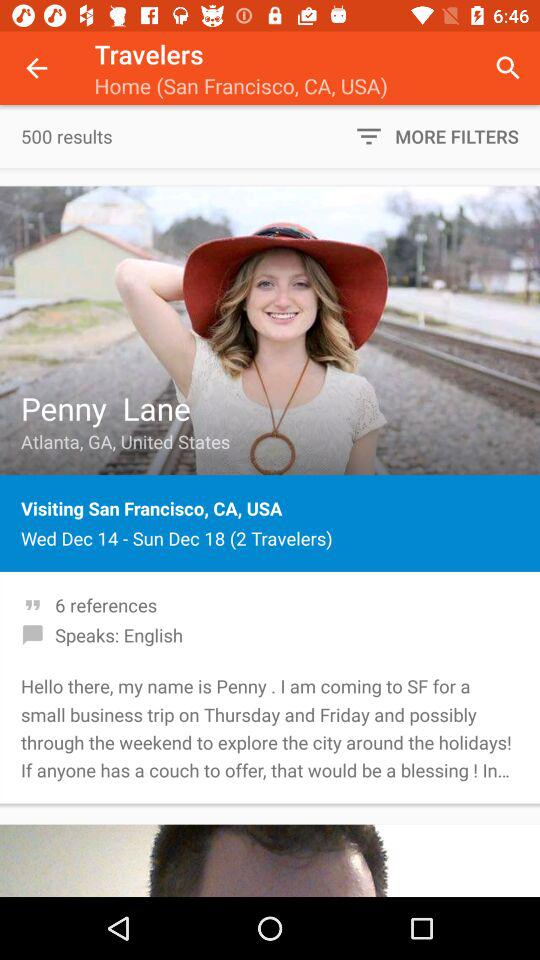How many people are in the group?
Answer the question using a single word or phrase. 2 